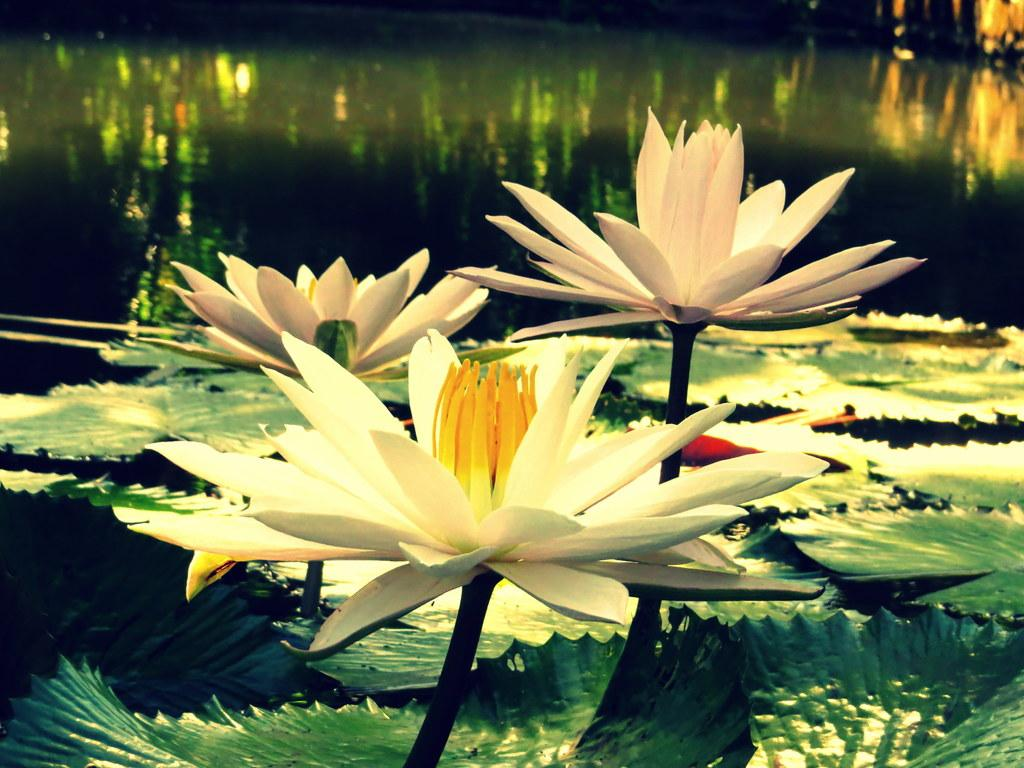What type of plants are visible in the image? There are lotuses in the image. What else can be seen in the image besides the lotuses? There are leaves in the image. Where are the lotuses and leaves located? Both the lotuses and leaves are on the water. How many fingers can be seen pointing at the lotuses in the image? There are no fingers visible in the image, as it only features lotuses and leaves on the water. 